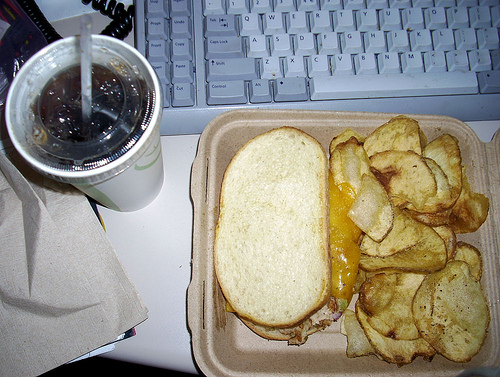Please identify all text content in this image. G F D S A Q W E R T Y H J U I O L K M N B V C X Z Shift Caps Lock 